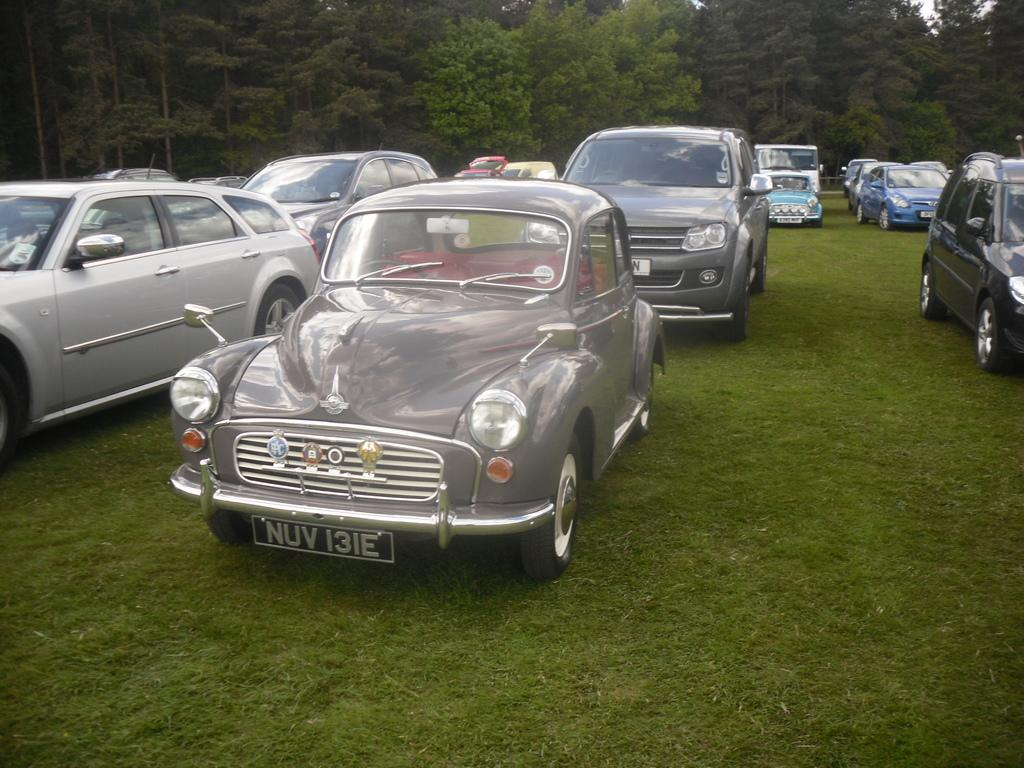What is the primary feature of the green land in the image? There are cars parked on the green land in the image. What can be seen in the background of the image? Trees are present in the background of the image. What type of nose can be seen on the cars in the image? There are no noses present on the cars in the image, as cars do not have noses. How can the cars be sorted in the image? The cars cannot be sorted in the image, as there is no information provided about their make, model, or color. 